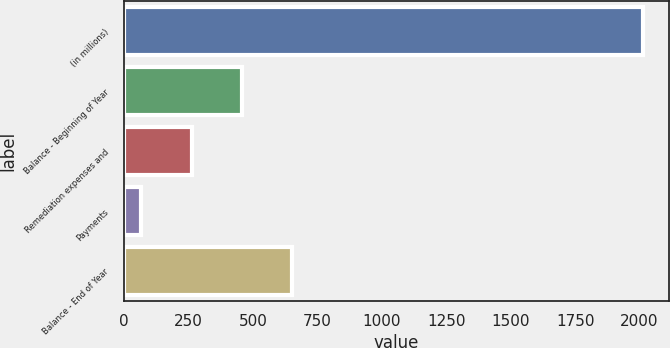<chart> <loc_0><loc_0><loc_500><loc_500><bar_chart><fcel>(in millions)<fcel>Balance - Beginning of Year<fcel>Remediation expenses and<fcel>Payments<fcel>Balance - End of Year<nl><fcel>2014<fcel>457.2<fcel>262.6<fcel>68<fcel>651.8<nl></chart> 